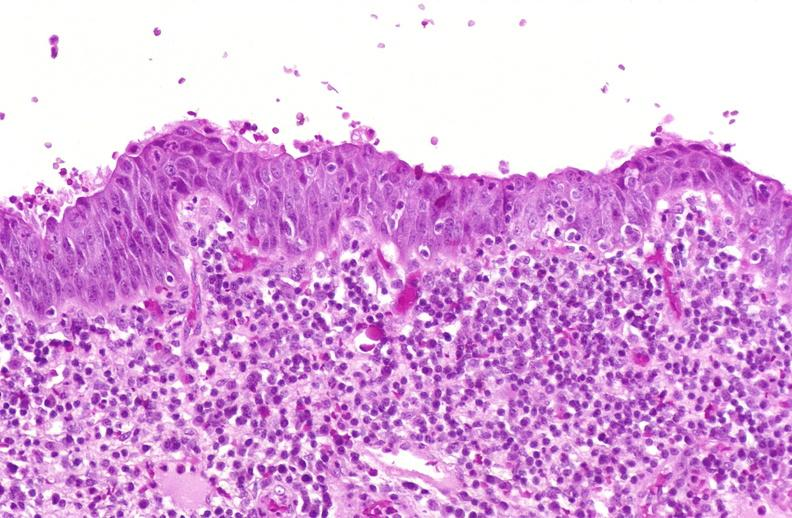s astrocytoma present?
Answer the question using a single word or phrase. No 